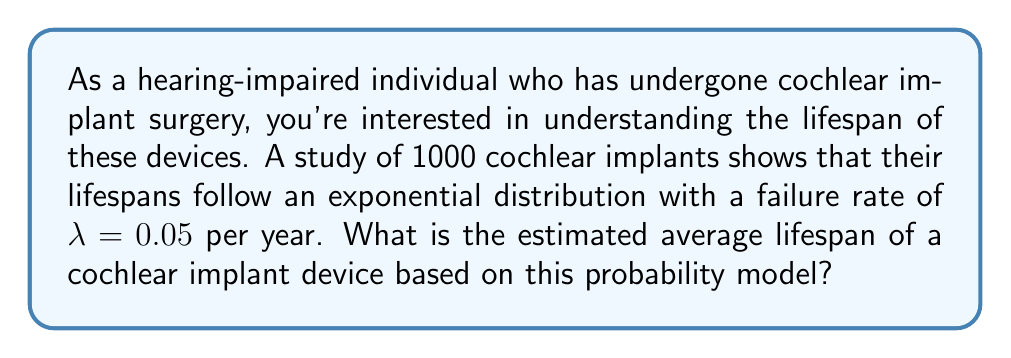Help me with this question. To solve this problem, we need to understand the properties of the exponential distribution and how it relates to the average lifespan of cochlear implants.

1) The exponential distribution is often used to model the time until an event occurs, such as the failure of a device. It's characterized by a single parameter $\lambda$, which is the failure rate.

2) For an exponential distribution, the average (or expected value) is given by:

   $E(X) = \frac{1}{\lambda}$

   where $X$ is the random variable representing the lifespan of a cochlear implant.

3) In this case, we're given that $\lambda = 0.05$ per year.

4) Substituting this value into our formula:

   $E(X) = \frac{1}{0.05}$

5) Calculating this:

   $E(X) = 20$ years

This means that, on average, a cochlear implant is expected to last 20 years before failing, according to this probability model.

It's important to note that this is an average. Some devices may fail earlier, while others may last longer. The exponential distribution has the property of being "memoryless," which means that the probability of failure in the next year is the same regardless of how long the device has already been functioning.
Answer: The estimated average lifespan of a cochlear implant device, based on the given exponential distribution model with $\lambda = 0.05$ per year, is 20 years. 